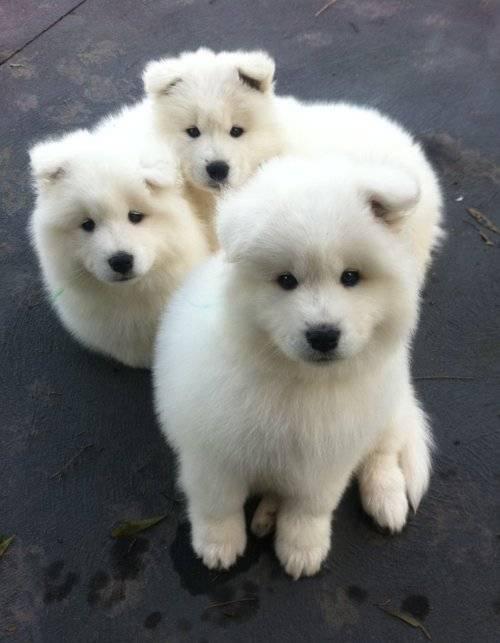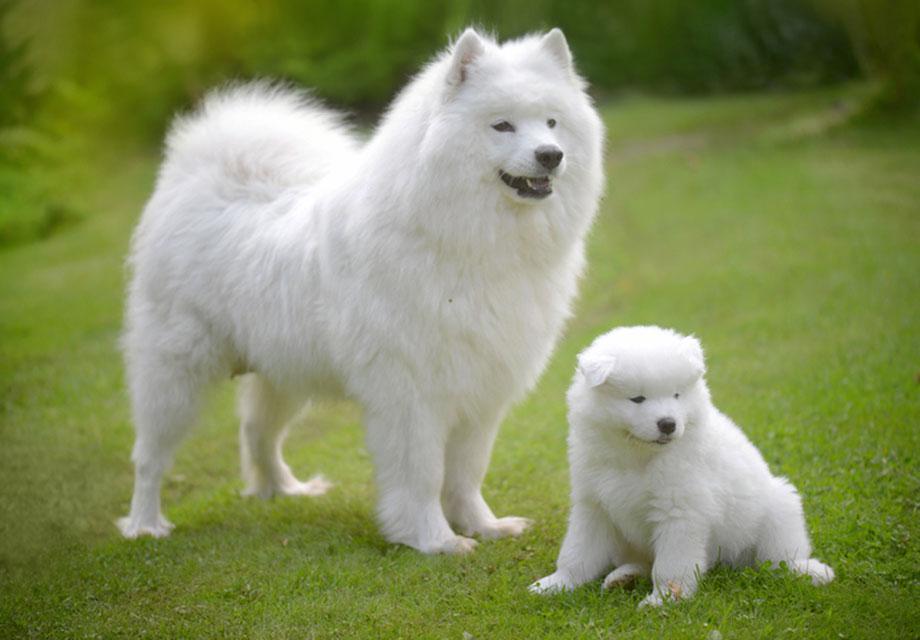The first image is the image on the left, the second image is the image on the right. Assess this claim about the two images: "There are a total of 5 white dogs.". Correct or not? Answer yes or no. Yes. 